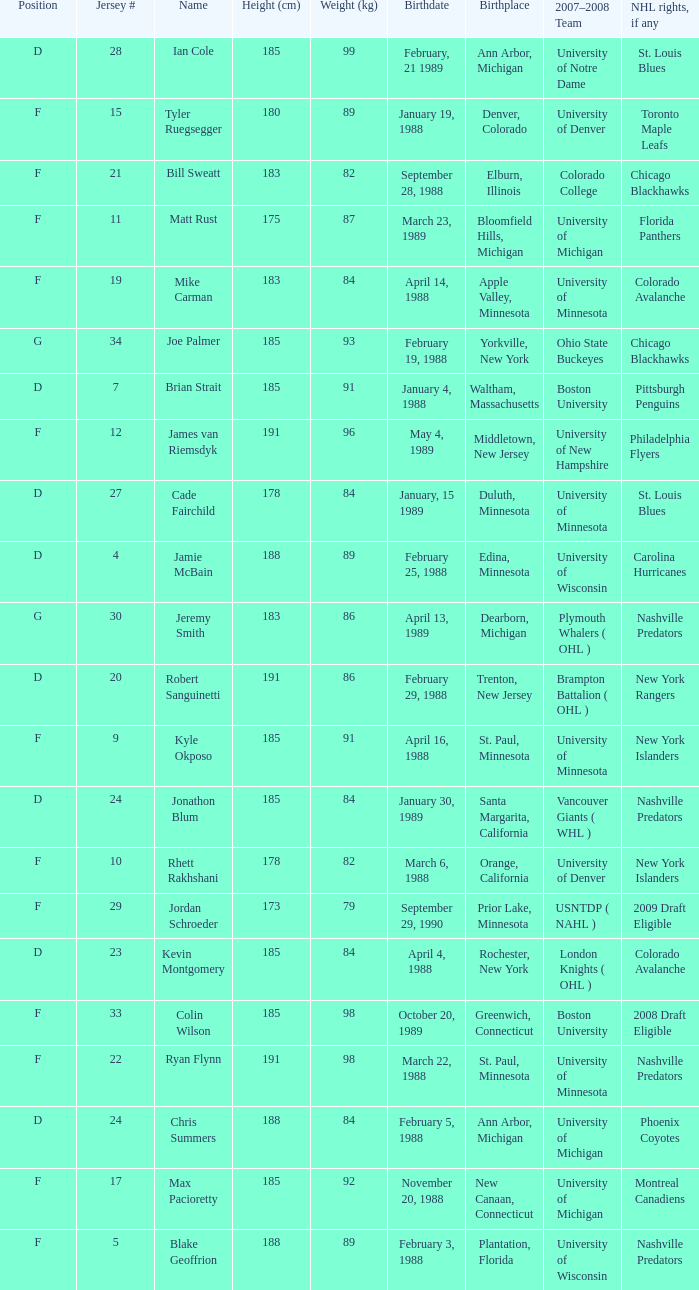Which Height (cm) has a Birthplace of bloomfield hills, michigan? 175.0. 